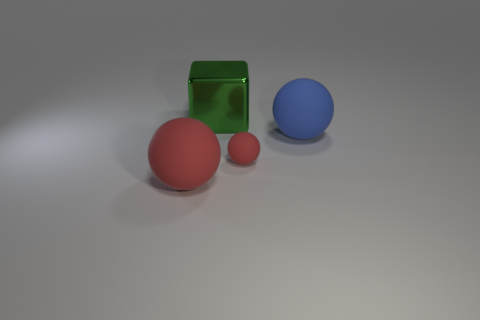Add 3 green metallic blocks. How many objects exist? 7 Subtract all blocks. How many objects are left? 3 Subtract all small red rubber objects. Subtract all red matte objects. How many objects are left? 1 Add 1 blue rubber spheres. How many blue rubber spheres are left? 2 Add 3 blue rubber spheres. How many blue rubber spheres exist? 4 Subtract 1 blue spheres. How many objects are left? 3 